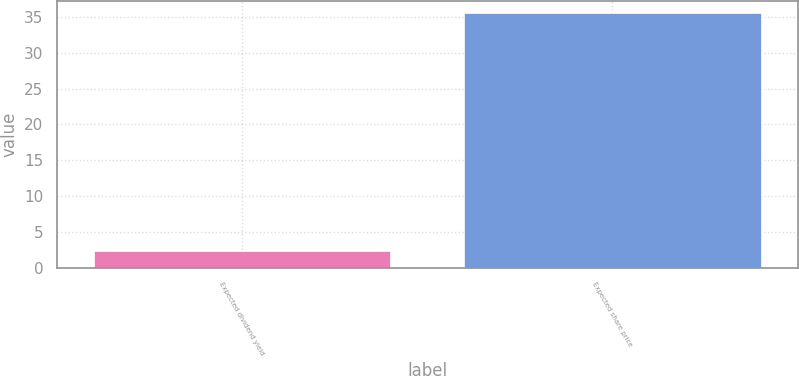<chart> <loc_0><loc_0><loc_500><loc_500><bar_chart><fcel>Expected dividend yield<fcel>Expected share price<nl><fcel>2.32<fcel>35.5<nl></chart> 